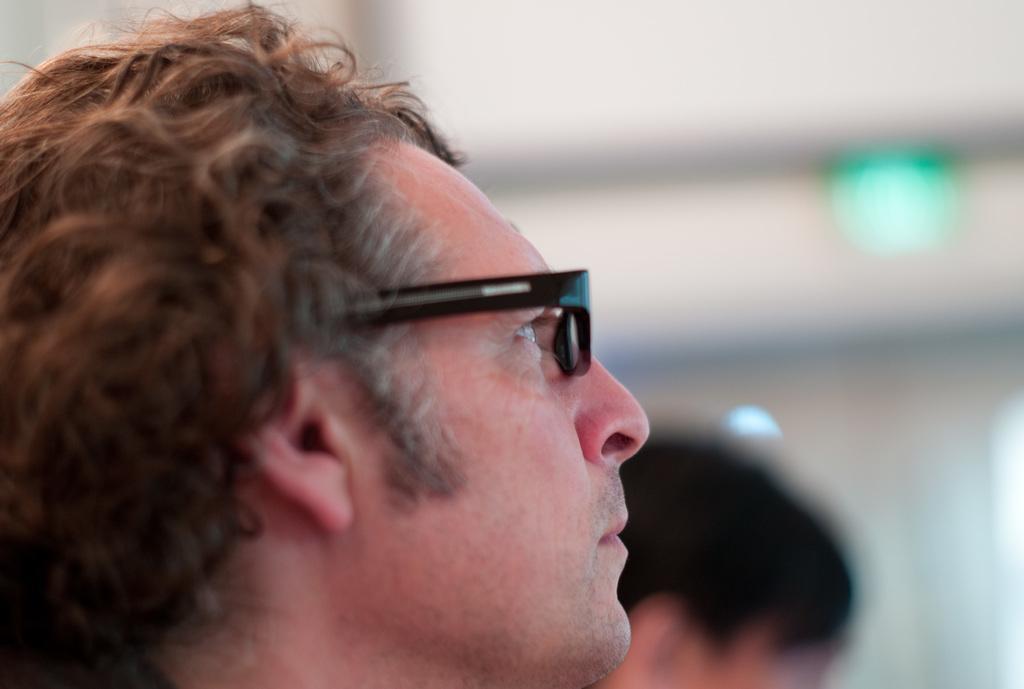Could you give a brief overview of what you see in this image? In this image there are two men on the right it is blurred. 